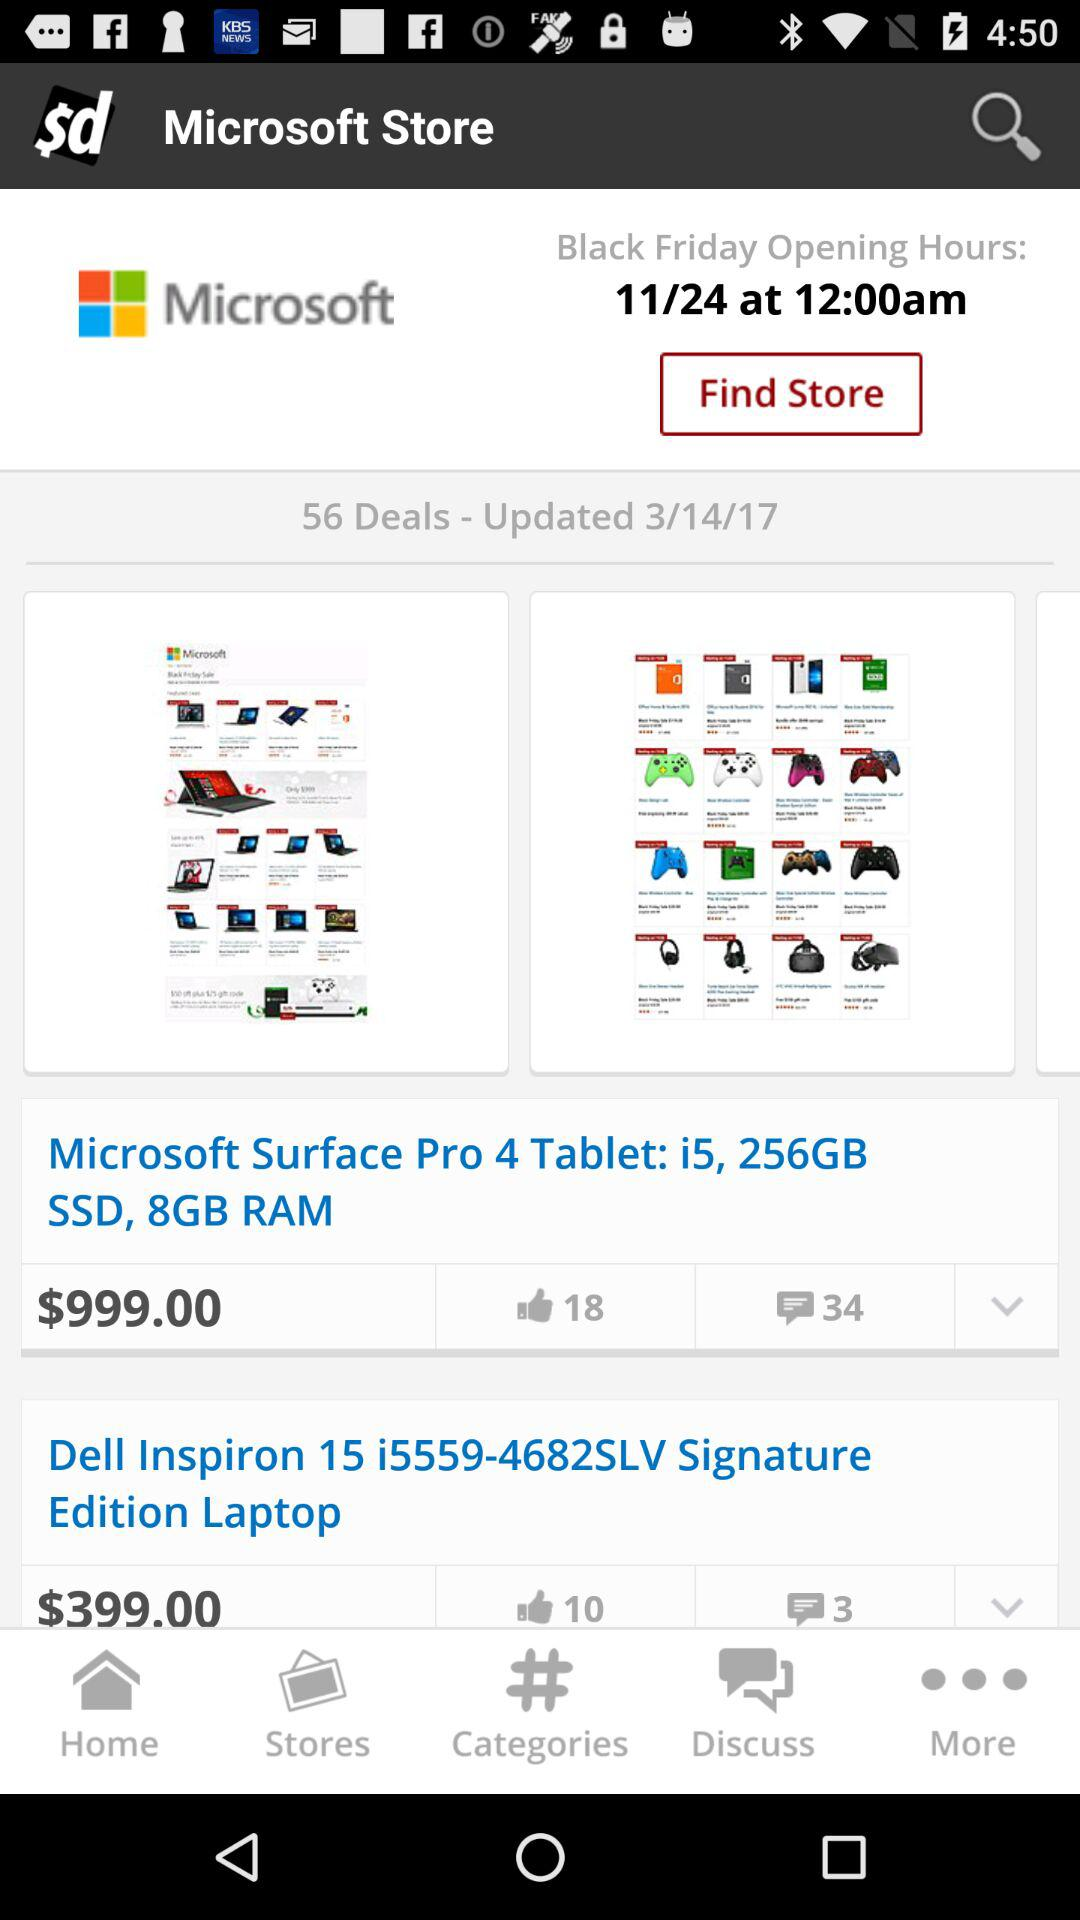What is the total number of deals shown on the screen? The total number of deals shown on the screen is 56. 